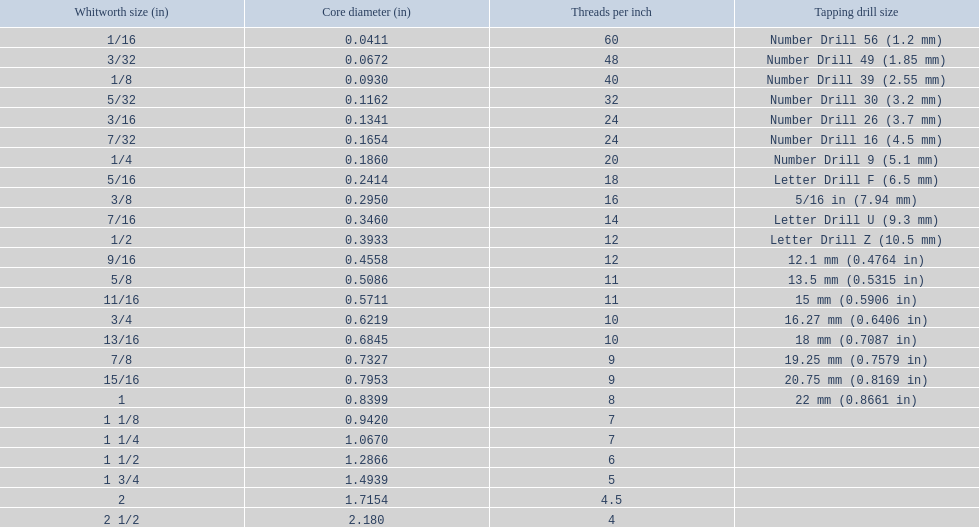What are all of the whitworth sizes? 1/16, 3/32, 1/8, 5/32, 3/16, 7/32, 1/4, 5/16, 3/8, 7/16, 1/2, 9/16, 5/8, 11/16, 3/4, 13/16, 7/8, 15/16, 1, 1 1/8, 1 1/4, 1 1/2, 1 3/4, 2, 2 1/2. How many threads per inch are in each size? 60, 48, 40, 32, 24, 24, 20, 18, 16, 14, 12, 12, 11, 11, 10, 10, 9, 9, 8, 7, 7, 6, 5, 4.5, 4. How many threads per inch are in the 3/16 size? 24. And which other size has the same number of threads? 7/32. 